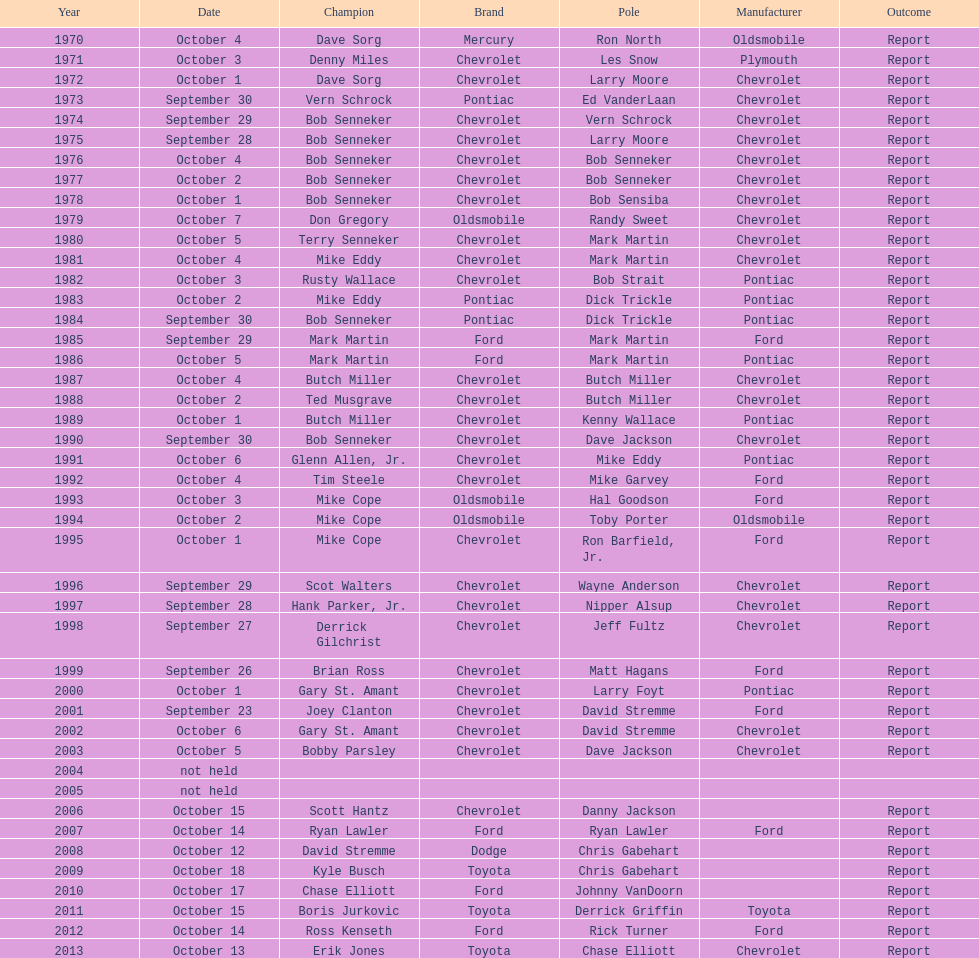How many consecutive wins did bob senneker have? 5. 